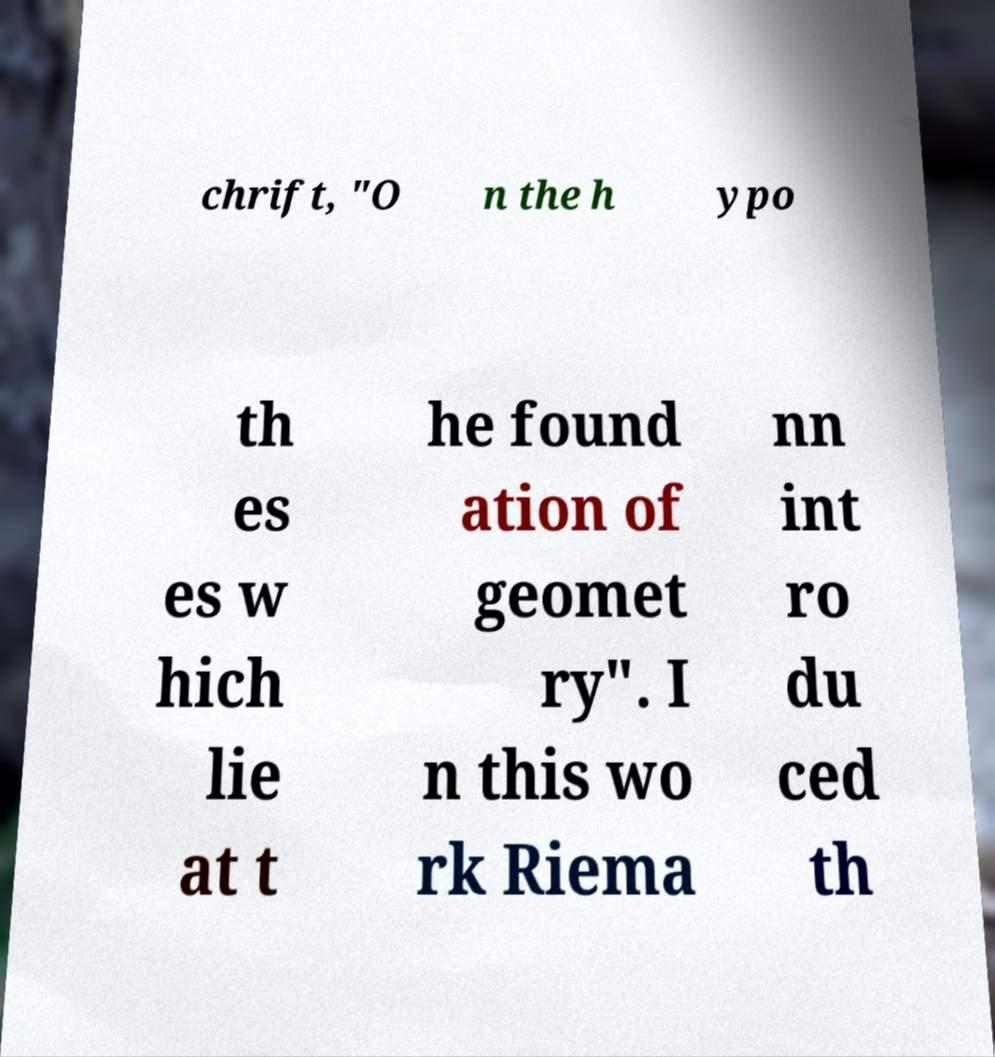Please identify and transcribe the text found in this image. chrift, "O n the h ypo th es es w hich lie at t he found ation of geomet ry". I n this wo rk Riema nn int ro du ced th 